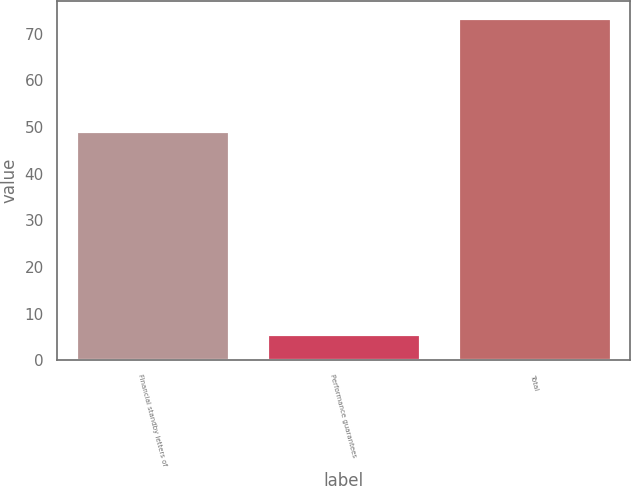Convert chart to OTSL. <chart><loc_0><loc_0><loc_500><loc_500><bar_chart><fcel>Financial standby letters of<fcel>Performance guarantees<fcel>Total<nl><fcel>49.2<fcel>5.7<fcel>73.4<nl></chart> 